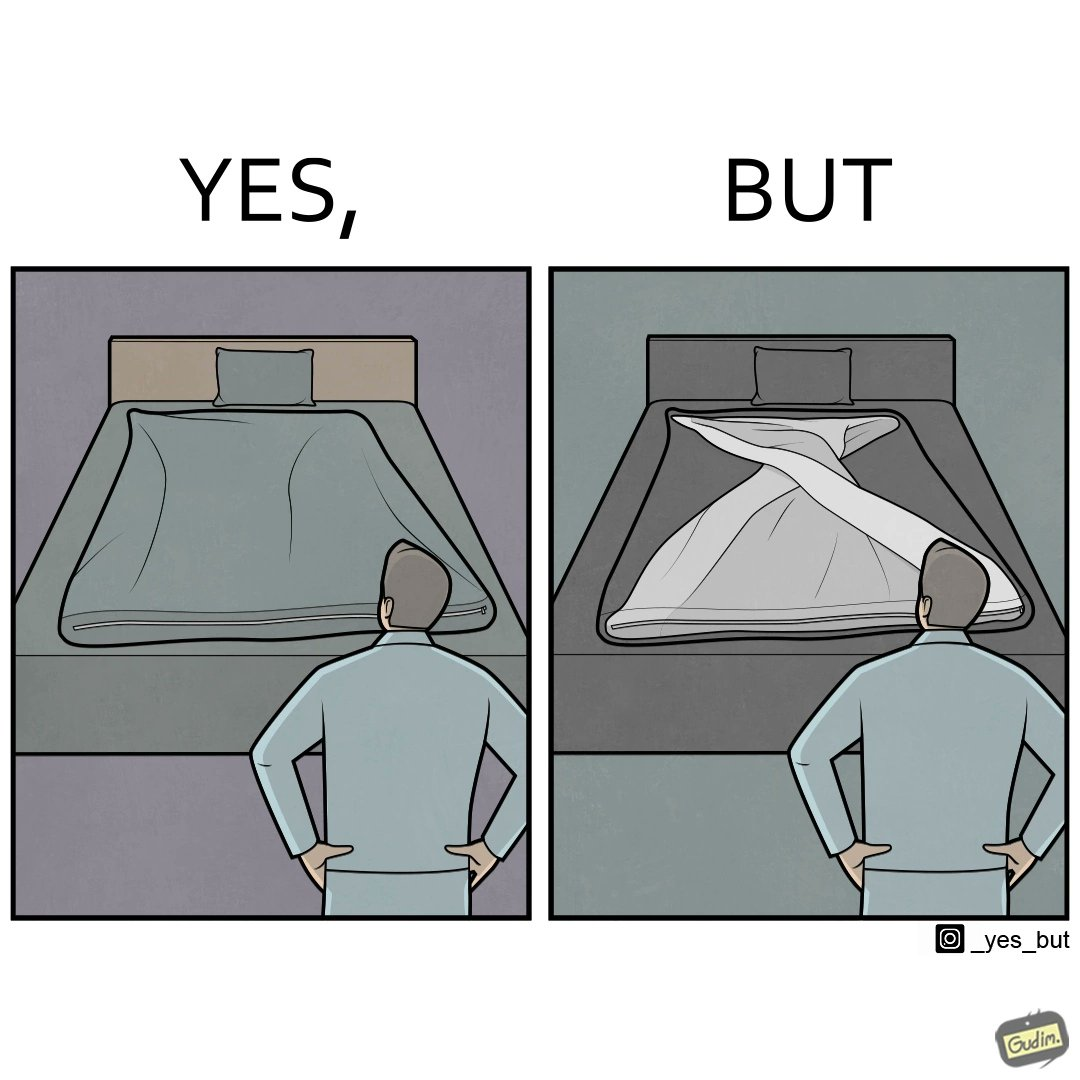Does this image contain satire or humor? Yes, this image is satirical. 